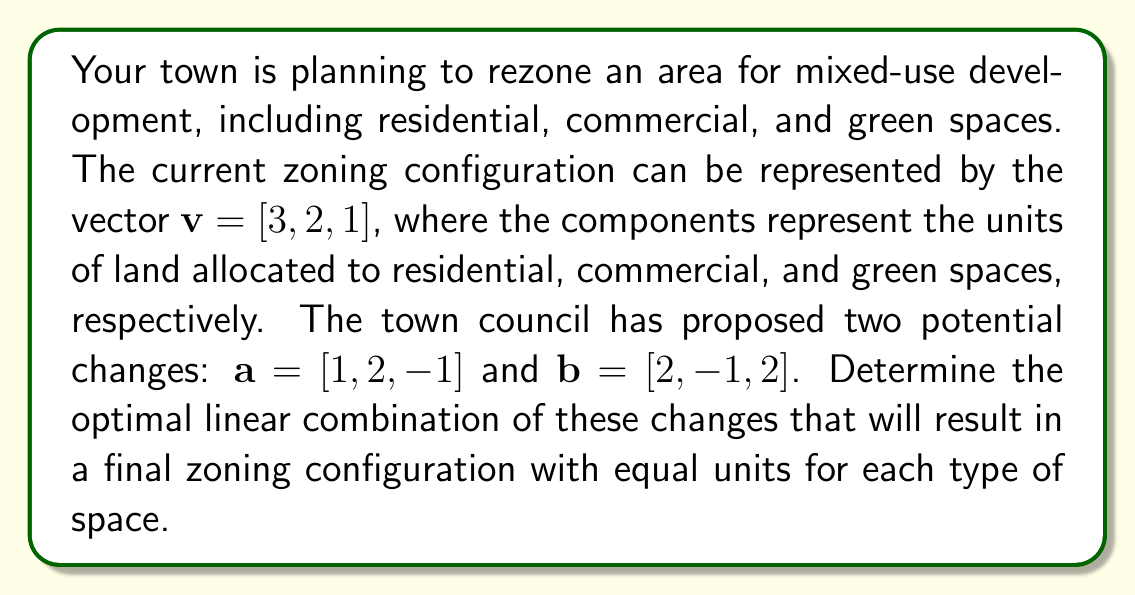What is the answer to this math problem? Let's approach this step-by-step:

1) We start with the initial configuration $v = [3, 2, 1]$.

2) We need to find scalars $x$ and $y$ such that $v + xa + yb$ results in a vector with equal components.

3) Let's set up the equation:
   $$v + xa + yb = [k, k, k]$$
   where $k$ is the desired equal number of units for each space type.

4) Expanding this:
   $$[3, 2, 1] + x[1, 2, -1] + y[2, -1, 2] = [k, k, k]$$

5) This gives us a system of linear equations:
   $$3 + x + 2y = k$$
   $$2 + 2x - y = k$$
   $$1 - x + 2y = k$$

6) Since we want all components to be equal, we can set these equations equal to each other:
   $$3 + x + 2y = 2 + 2x - y = 1 - x + 2y$$

7) From the first and second equation:
   $$3 + x + 2y = 2 + 2x - y$$
   $$1 = x - 3y$$
   $$x = 1 + 3y$$

8) Substituting this into the equation from the first and third:
   $$3 + (1 + 3y) + 2y = 1 - (1 + 3y) + 2y$$
   $$4 + 5y = -y$$
   $$6y = -4$$
   $$y = -\frac{2}{3}$$

9) Now we can find $x$:
   $$x = 1 + 3(-\frac{2}{3}) = 1 - 2 = -1$$

10) To find $k$, we can substitute these values into any of the original equations:
    $$k = 3 + (-1) + 2(-\frac{2}{3}) = 3 - 1 - \frac{4}{3} = \frac{2}{3}$$

Therefore, the optimal linear combination is $-1$ times the first proposed change and $-\frac{2}{3}$ times the second proposed change.
Answer: $x = -1, y = -\frac{2}{3}$ 